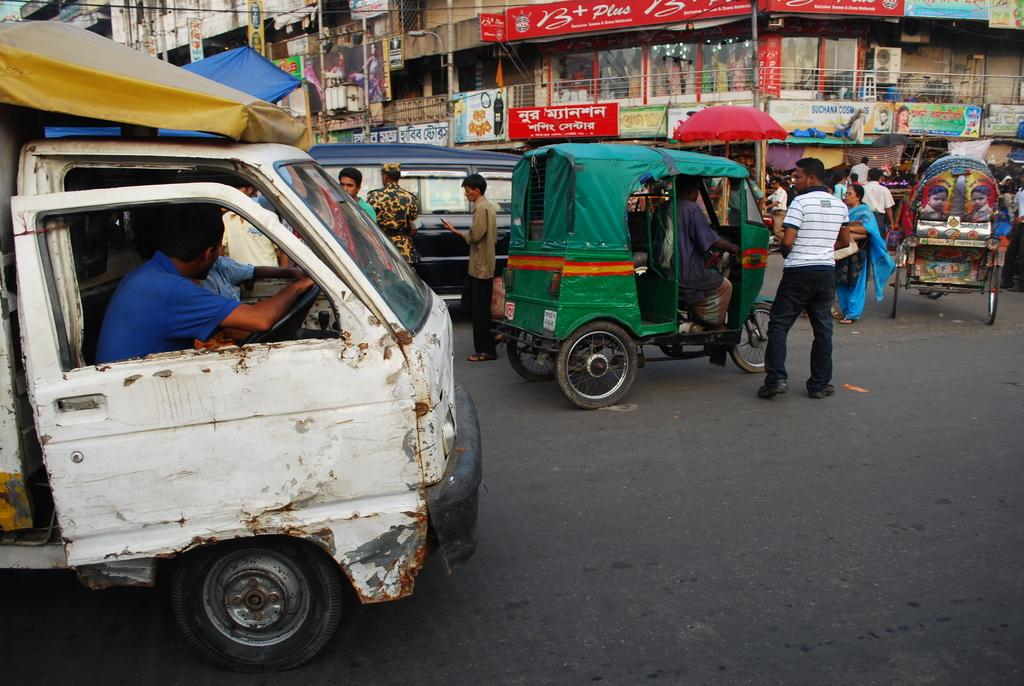<image>
Summarize the visual content of the image. A sign with the word "Suchana" in blue letters hangs near a red umbrella. 